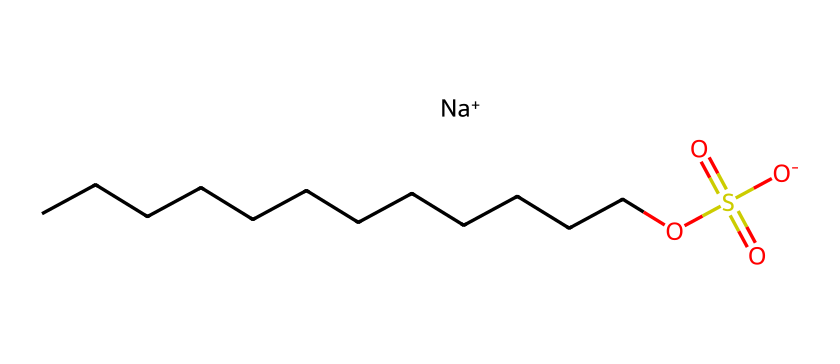What is the name of this chemical? The SMILES representation indicates that the chemical is Sodium Lauryl Sulfate, which is a common name for this compound. The structure shows a long hydrocarbon chain with a sulfate group, typical of lauryl sulfate.
Answer: Sodium Lauryl Sulfate How many carbon atoms are present in this structure? By analyzing the longest carbon chain in the SMILES representation, there are 12 carbon atoms indicated by "CCCCCCCCCCCC".
Answer: 12 What is the charge of the sodium ion in this compound? The SMILES structure shows "[Na+]", indicating that the sodium atom has a +1 charge.
Answer: +1 Which functional group is responsible for its foaming properties? The sulfate group "OS(=O)(=O)[O-]" in the structure is responsible for the foaming properties, as it interacts well with water and oils, allowing bubbles to form.
Answer: Sulfate group What type of chemical is Sodium Lauryl Sulfate? Sodium Lauryl Sulfate is classified as an anionic surfactant, evident by the presence of the negatively charged sulfate group that allows it to reduce surface tension.
Answer: Anionic surfactant How does the carbon chain length impact the properties of the compound? The long carbon chain contributes to the hydrophobic characteristics of the molecule, which affects its ability to interact with oils and dirt, enhancing cleansing action. Longer chains generally increase foaming ability.
Answer: Increases foaming ability 